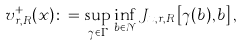<formula> <loc_0><loc_0><loc_500><loc_500>v _ { r , R } ^ { + } ( x ) \colon = \sup _ { \gamma \in \Gamma } \inf _ { b \in \mathcal { N } } J _ { x , r , R } \left [ \gamma ( b ) , b \right ] ,</formula> 